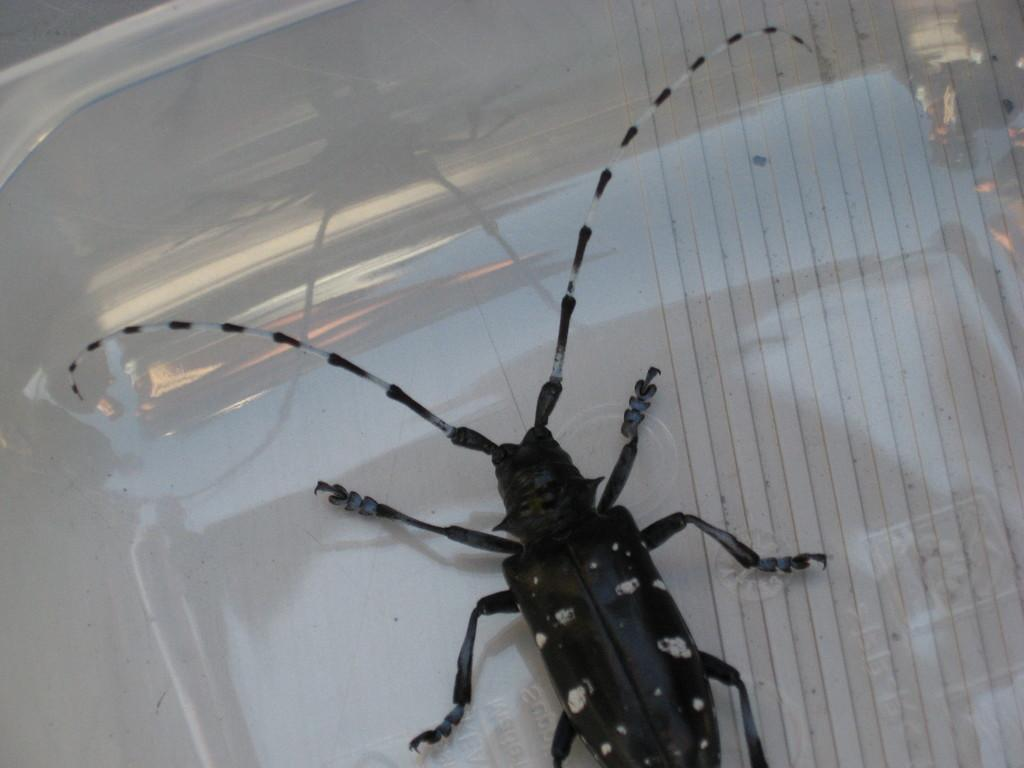What type of creature is in the image? There is an insect in the image. Where is the insect located? The insect is on a platform. What type of rabbit is wearing apparel in the image? There is no rabbit or apparel present in the image; it only features an insect on a platform. What type of harmony is depicted in the image? There is no depiction of harmony in the image, as it only features an insect on a platform. 